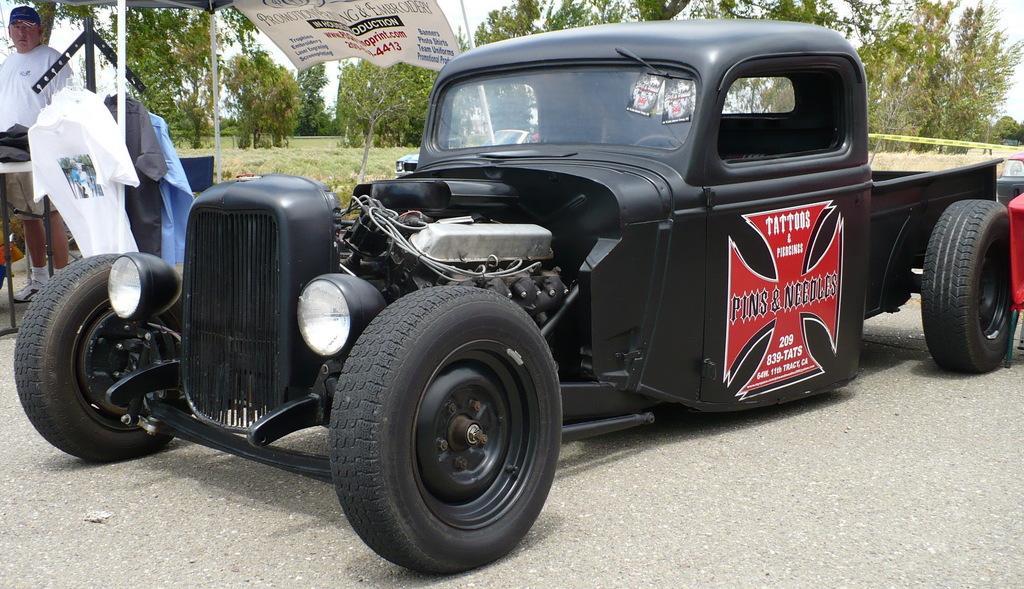Can you describe this image briefly? In this image, this looks like a vehicle, which is black in color. I think this is an engine. These are the wheels, headlights, glass wiper are attached to the vehicle. This looks like a sticker, which is attached to the door. Here is a person standing. These are the clothes hanging. This looks like a banner. I can see the trees. This looks like a grass. 